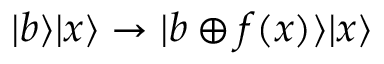Convert formula to latex. <formula><loc_0><loc_0><loc_500><loc_500>| b \rangle | x \rangle \to | b \oplus f ( x ) \rangle | x \rangle</formula> 